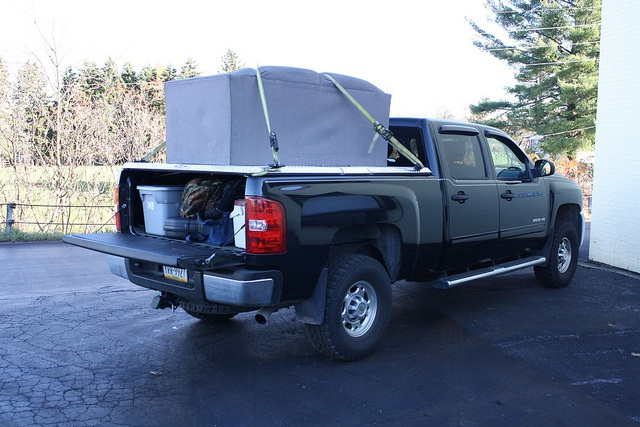Describe the objects in this image and their specific colors. I can see truck in white, black, navy, gray, and darkgray tones, couch in white, gray, and darkgray tones, backpack in white, black, gray, navy, and blue tones, backpack in white, black, navy, darkblue, and gray tones, and suitcase in white, navy, darkblue, black, and gray tones in this image. 